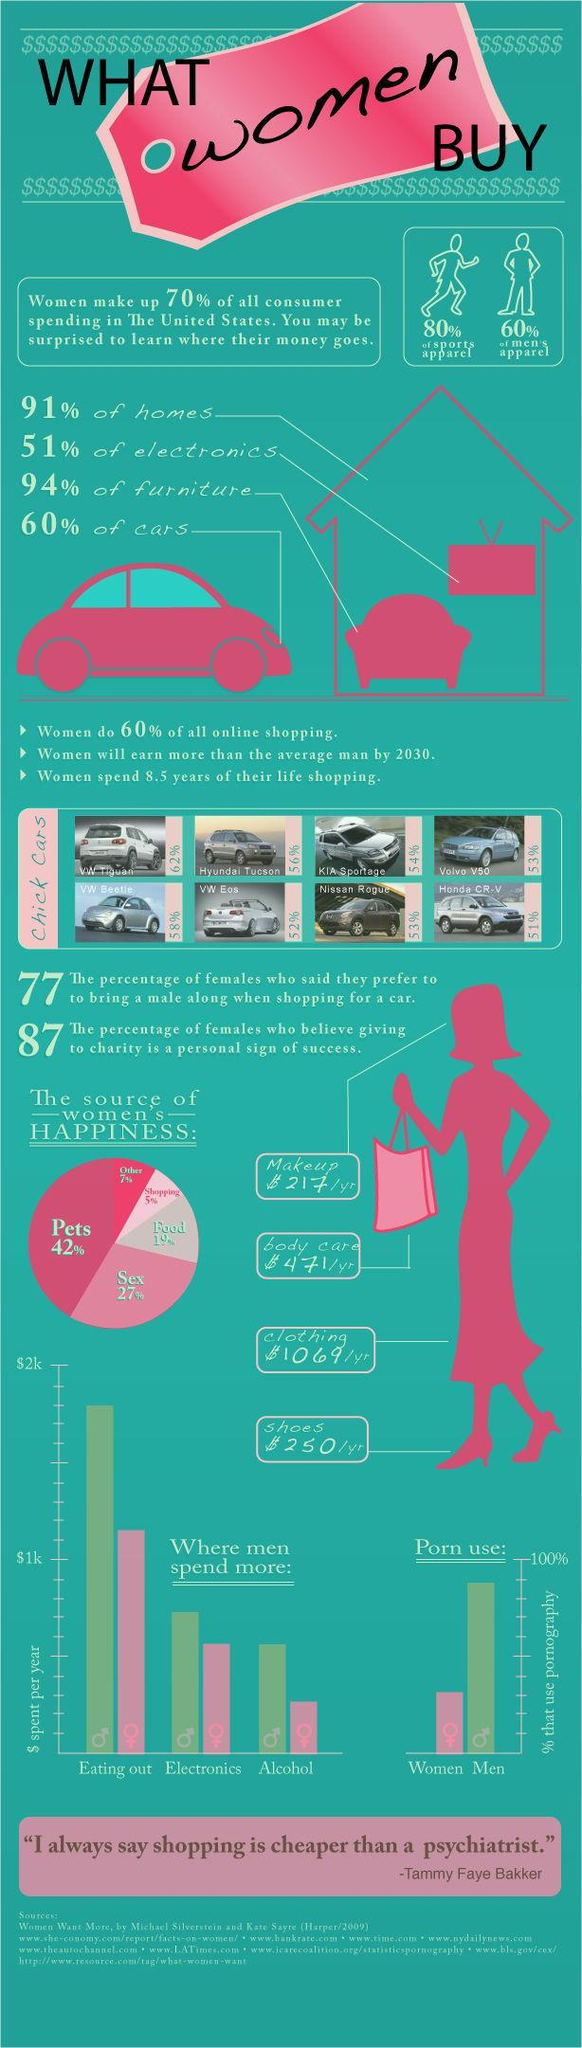How much money is spend on body care by women in the U.S.?
Answer the question with a short phrase. $ 471/yr What percent of women in the U.S. felt happy by shopping? 5% What is the source of happiness for the majority of women in the U.S.? Pets 